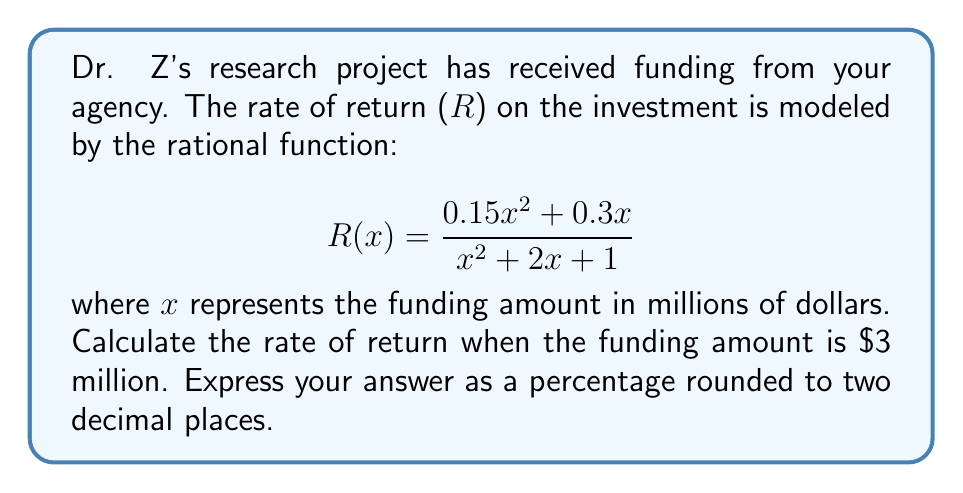What is the answer to this math problem? To solve this problem, we'll follow these steps:

1) We're given the rational function for the rate of return:
   $$R(x) = \frac{0.15x^2 + 0.3x}{x^2 + 2x + 1}$$

2) We need to calculate R(3) since the funding amount is $3 million:
   $$R(3) = \frac{0.15(3)^2 + 0.3(3)}{(3)^2 + 2(3) + 1}$$

3) Let's calculate the numerator:
   $0.15(3)^2 + 0.3(3) = 0.15(9) + 0.9 = 1.35 + 0.9 = 2.25$

4) Now the denominator:
   $(3)^2 + 2(3) + 1 = 9 + 6 + 1 = 16$

5) Putting it together:
   $$R(3) = \frac{2.25}{16} = 0.140625$$

6) Convert to a percentage by multiplying by 100:
   $0.140625 * 100 = 14.0625\%$

7) Rounding to two decimal places:
   $14.06\%$
Answer: 14.06% 